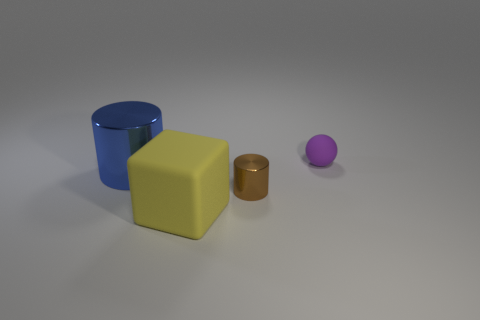Add 2 large blue cylinders. How many objects exist? 6 Subtract all balls. How many objects are left? 3 Add 2 tiny purple objects. How many tiny purple objects are left? 3 Add 2 small purple things. How many small purple things exist? 3 Subtract 0 gray cylinders. How many objects are left? 4 Subtract all tiny cyan metallic cylinders. Subtract all big rubber blocks. How many objects are left? 3 